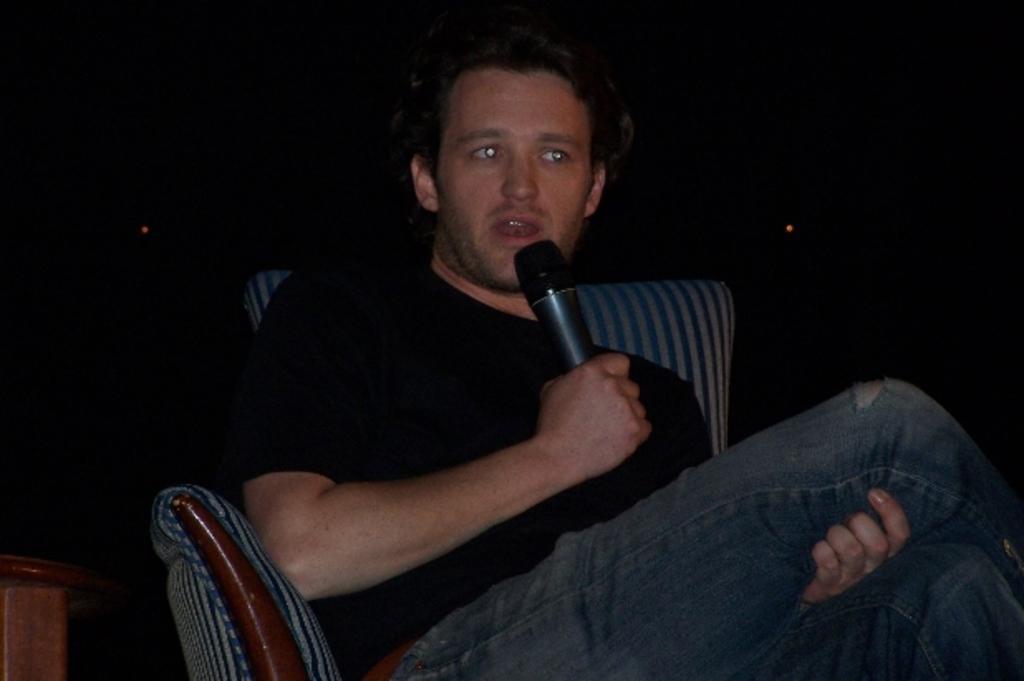Could you give a brief overview of what you see in this image? In the picture we can see a man sitting on the chair and holding a microphone, he is wearing a black T-shirt with blue jeans, in the background there is a dark in color. 